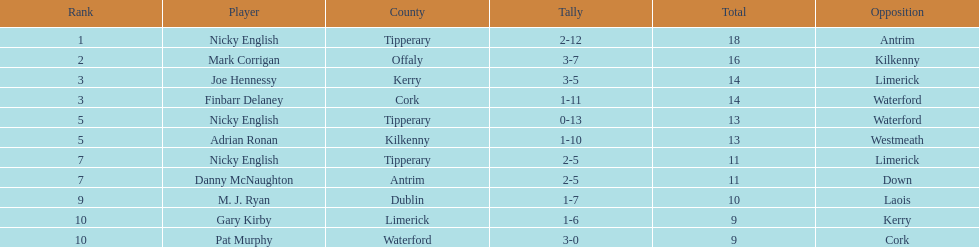What player got 10 total points in their game? M. J. Ryan. 